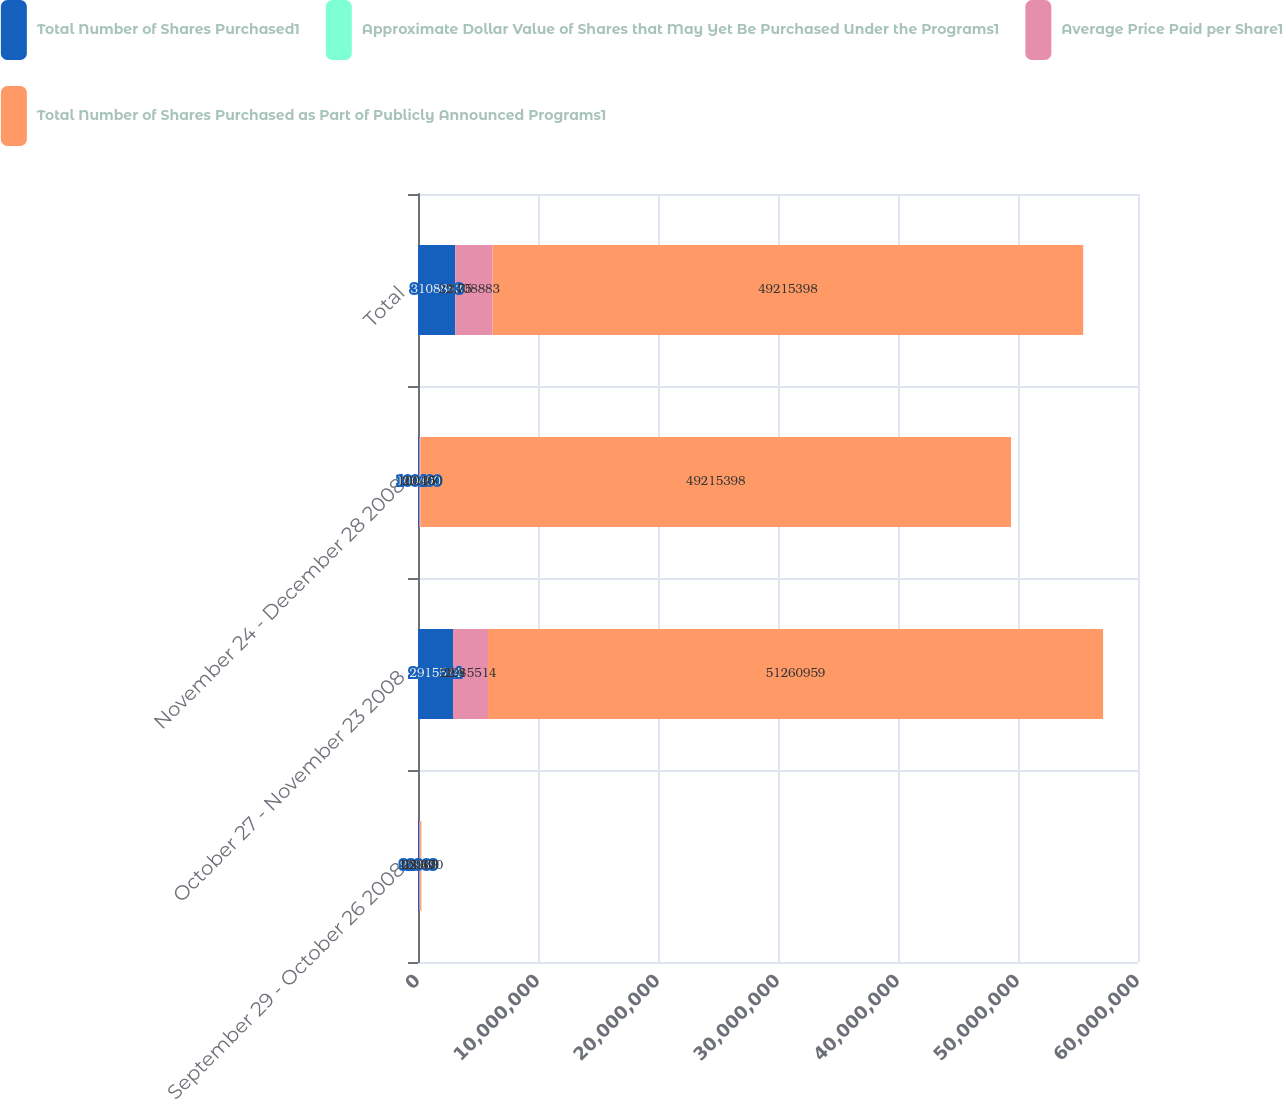Convert chart. <chart><loc_0><loc_0><loc_500><loc_500><stacked_bar_chart><ecel><fcel>September 29 - October 26 2008<fcel>October 27 - November 23 2008<fcel>November 24 - December 28 2008<fcel>Total<nl><fcel>Total Number of Shares Purchased1<fcel>92969<fcel>2.91551e+06<fcel>100400<fcel>3.10888e+06<nl><fcel>Approximate Dollar Value of Shares that May Yet Be Purchased Under the Programs1<fcel>23.67<fcel>22.8<fcel>20.35<fcel>22.75<nl><fcel>Average Price Paid per Share1<fcel>92969<fcel>2.91551e+06<fcel>100400<fcel>3.10888e+06<nl><fcel>Total Number of Shares Purchased as Part of Publicly Announced Programs1<fcel>100400<fcel>5.1261e+07<fcel>4.92154e+07<fcel>4.92154e+07<nl></chart> 